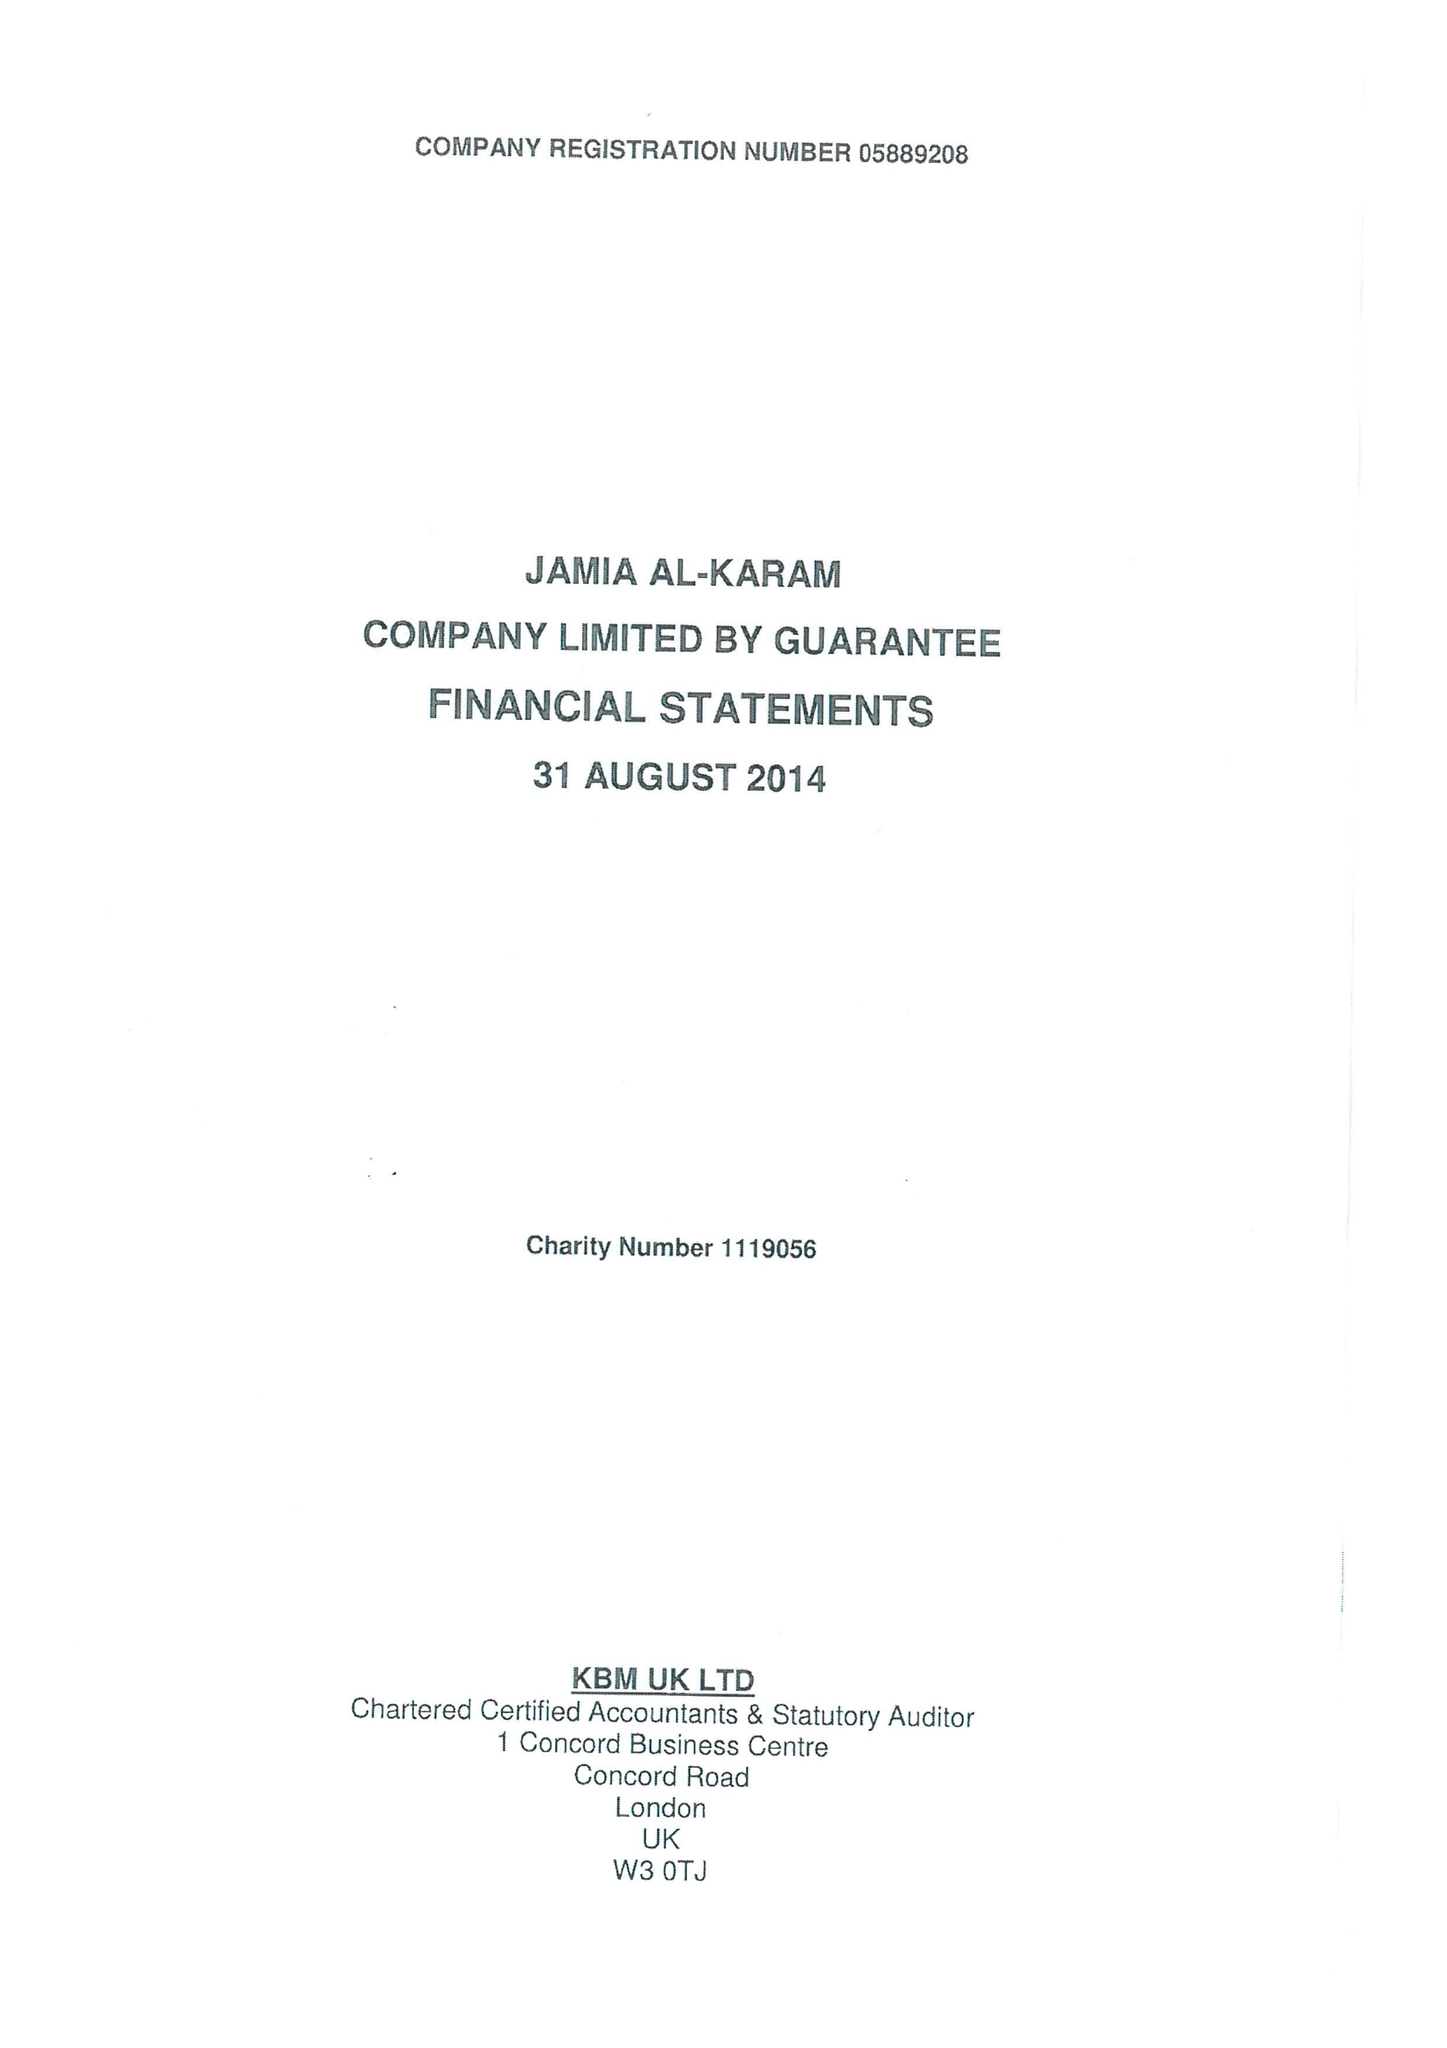What is the value for the address__postcode?
Answer the question using a single word or phrase. DN22 0PR 